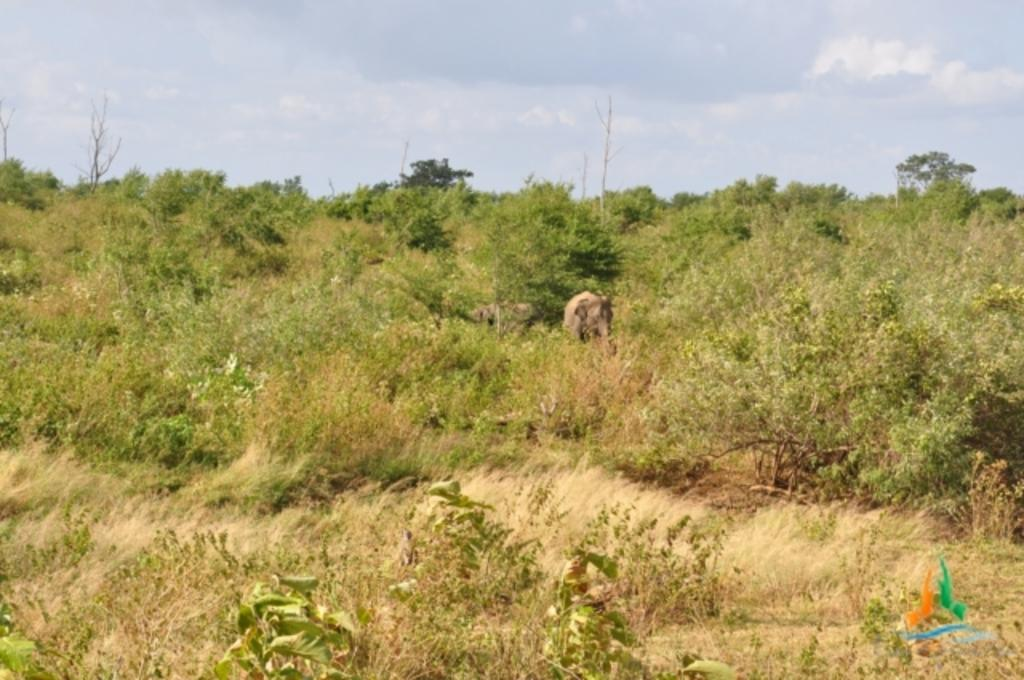What type of vegetation is present on the ground in the image? There are plants and trees on the ground in the image. Can you describe the sky in the image? The sky is clear in the image. How much tin can be seen in the image? There is no tin present in the image. Is there a farmer visible in the image? There is no farmer present in the image. 